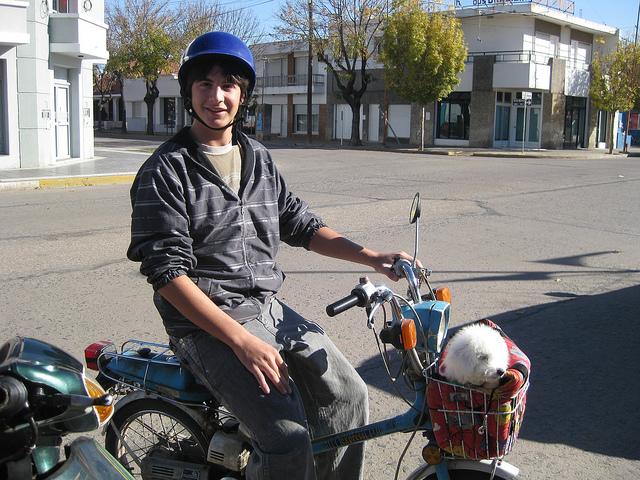What safety gear is this person wearing?
Short answer required. Helmet. What is in the basket?
Write a very short answer. Dog. Is this a nice bike?
Quick response, please. Yes. 